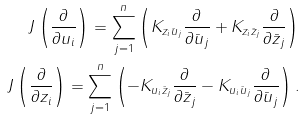<formula> <loc_0><loc_0><loc_500><loc_500>J \left ( \frac { \partial } { \partial u _ { i } } \right ) = \sum _ { j = 1 } ^ { n } \left ( K _ { z _ { i } \bar { u } _ { j } } \frac { \partial } { \partial \bar { u } _ { j } } + K _ { z _ { i } \bar { z } _ { j } } \frac { \partial } { \partial \bar { z } _ { j } } \right ) \\ J \left ( \frac { \partial } { \partial z _ { i } } \right ) = \sum _ { j = 1 } ^ { n } \left ( - K _ { u _ { i } \bar { z } _ { j } } \frac { \partial } { \partial \bar { z } _ { j } } - K _ { u _ { i } \bar { u } _ { j } } \frac { \partial } { \partial \bar { u } _ { j } } \right ) .</formula> 